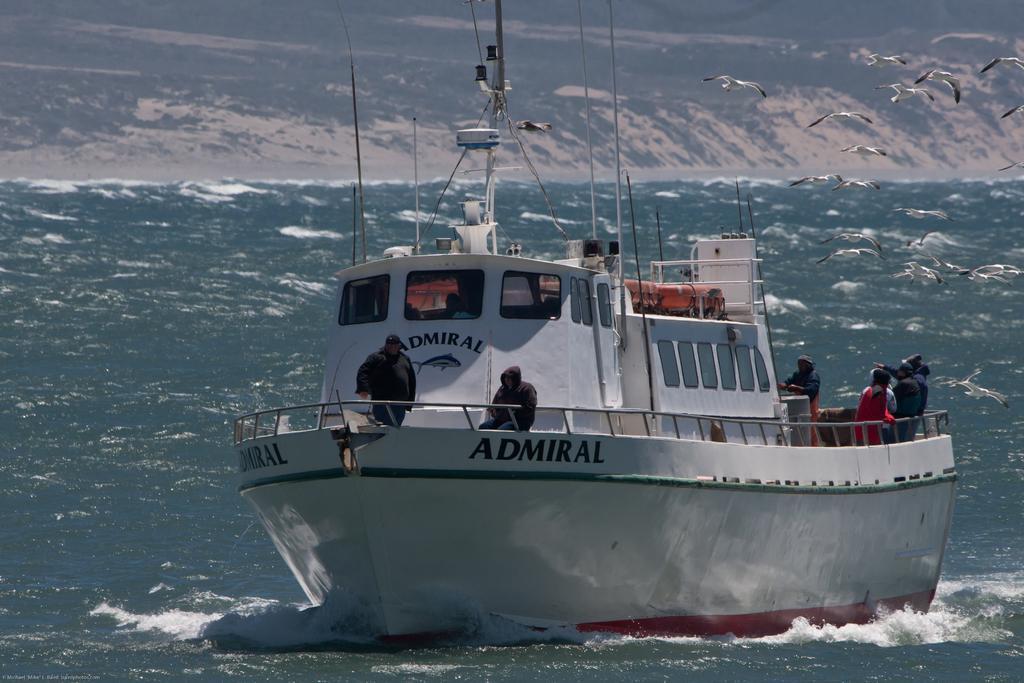Describe this image in one or two sentences. In the image we can see there is a boat in the water. In the boat we can see there are people standing, wearing clothes and some of them are wearing caps. Here we can see the sea, pole and the hill. We can see there are even birds flying. 